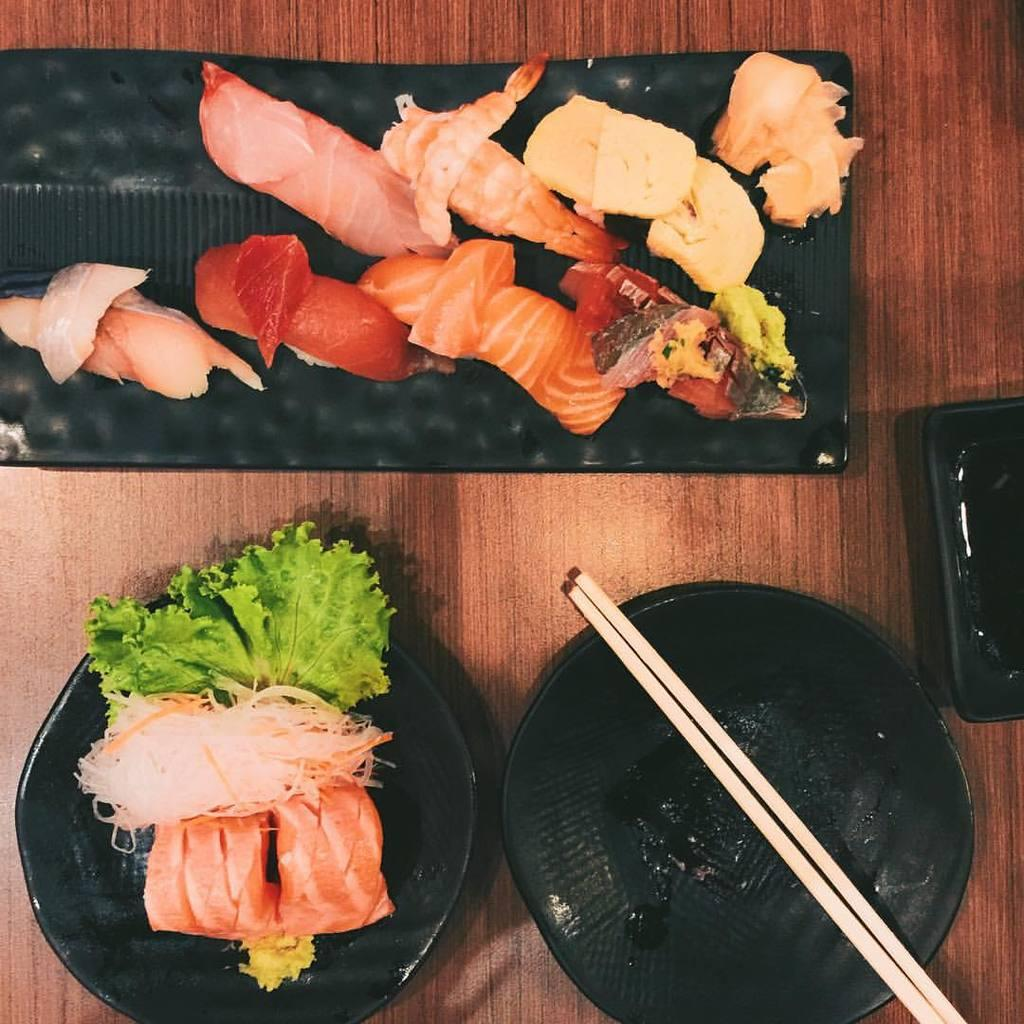What is on the plate that is visible in the image? There is food placed on a plate in the image. Where is the plate located in the image? The plate is on a table in the image. What utensil is present in the image? Chopsticks are present in the image. What is the man's opinion about the food on the plate in the image? There is no man present in the image, so it is not possible to determine his opinion about the food. 